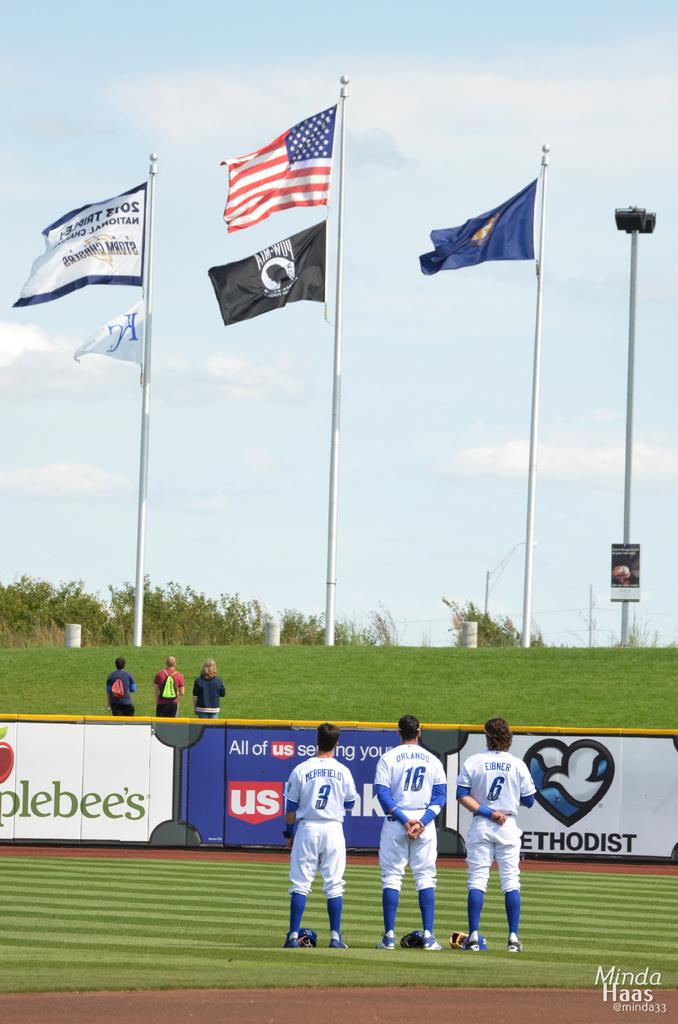Who sponsors this event?
Your answer should be very brief. Applebee's. What number is the player on the very right?
Provide a succinct answer. 6. 